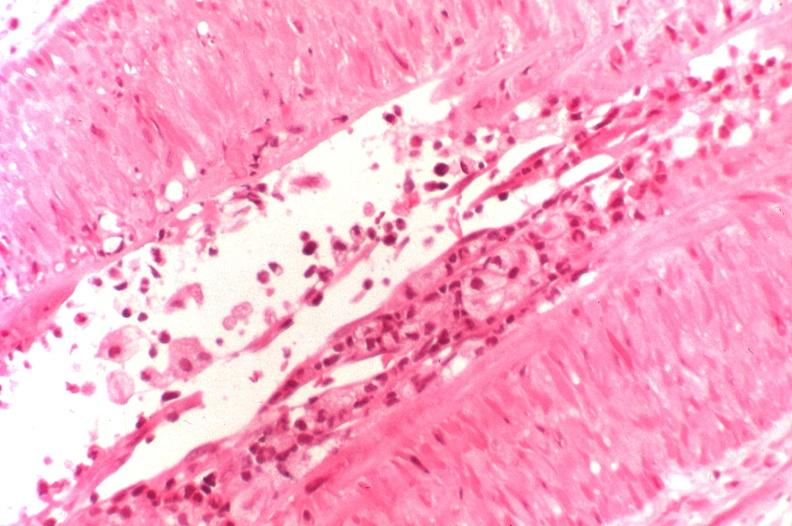where is this?
Answer the question using a single word or phrase. Urinary 